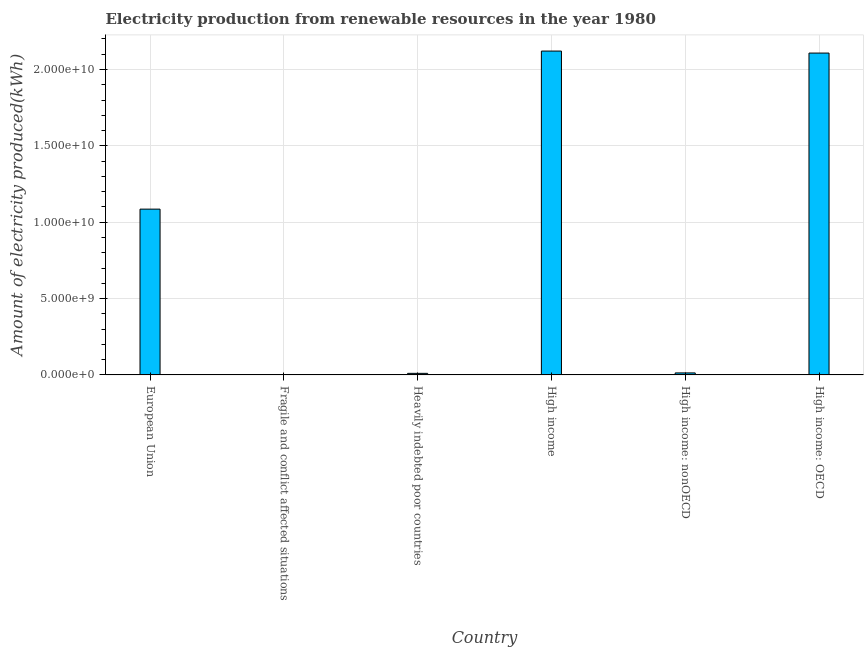Does the graph contain any zero values?
Offer a very short reply. No. What is the title of the graph?
Your answer should be very brief. Electricity production from renewable resources in the year 1980. What is the label or title of the X-axis?
Your answer should be compact. Country. What is the label or title of the Y-axis?
Your answer should be compact. Amount of electricity produced(kWh). What is the amount of electricity produced in Fragile and conflict affected situations?
Keep it short and to the point. 1.20e+07. Across all countries, what is the maximum amount of electricity produced?
Offer a terse response. 2.12e+1. Across all countries, what is the minimum amount of electricity produced?
Your answer should be very brief. 1.20e+07. In which country was the amount of electricity produced minimum?
Offer a very short reply. Fragile and conflict affected situations. What is the sum of the amount of electricity produced?
Your response must be concise. 5.34e+1. What is the difference between the amount of electricity produced in European Union and High income: nonOECD?
Offer a very short reply. 1.07e+1. What is the average amount of electricity produced per country?
Keep it short and to the point. 8.90e+09. What is the median amount of electricity produced?
Provide a succinct answer. 5.49e+09. In how many countries, is the amount of electricity produced greater than 19000000000 kWh?
Make the answer very short. 2. What is the ratio of the amount of electricity produced in Heavily indebted poor countries to that in High income?
Your response must be concise. 0.01. Is the difference between the amount of electricity produced in European Union and Heavily indebted poor countries greater than the difference between any two countries?
Keep it short and to the point. No. What is the difference between the highest and the second highest amount of electricity produced?
Your answer should be compact. 1.31e+08. What is the difference between the highest and the lowest amount of electricity produced?
Provide a succinct answer. 2.12e+1. How many bars are there?
Your answer should be compact. 6. Are all the bars in the graph horizontal?
Offer a very short reply. No. What is the difference between two consecutive major ticks on the Y-axis?
Provide a short and direct response. 5.00e+09. What is the Amount of electricity produced(kWh) of European Union?
Ensure brevity in your answer.  1.09e+1. What is the Amount of electricity produced(kWh) in Fragile and conflict affected situations?
Your answer should be compact. 1.20e+07. What is the Amount of electricity produced(kWh) of Heavily indebted poor countries?
Provide a short and direct response. 1.02e+08. What is the Amount of electricity produced(kWh) of High income?
Your answer should be very brief. 2.12e+1. What is the Amount of electricity produced(kWh) of High income: nonOECD?
Provide a succinct answer. 1.31e+08. What is the Amount of electricity produced(kWh) of High income: OECD?
Keep it short and to the point. 2.11e+1. What is the difference between the Amount of electricity produced(kWh) in European Union and Fragile and conflict affected situations?
Provide a succinct answer. 1.08e+1. What is the difference between the Amount of electricity produced(kWh) in European Union and Heavily indebted poor countries?
Your answer should be very brief. 1.08e+1. What is the difference between the Amount of electricity produced(kWh) in European Union and High income?
Your answer should be compact. -1.04e+1. What is the difference between the Amount of electricity produced(kWh) in European Union and High income: nonOECD?
Provide a succinct answer. 1.07e+1. What is the difference between the Amount of electricity produced(kWh) in European Union and High income: OECD?
Make the answer very short. -1.02e+1. What is the difference between the Amount of electricity produced(kWh) in Fragile and conflict affected situations and Heavily indebted poor countries?
Give a very brief answer. -9.00e+07. What is the difference between the Amount of electricity produced(kWh) in Fragile and conflict affected situations and High income?
Offer a terse response. -2.12e+1. What is the difference between the Amount of electricity produced(kWh) in Fragile and conflict affected situations and High income: nonOECD?
Your answer should be compact. -1.19e+08. What is the difference between the Amount of electricity produced(kWh) in Fragile and conflict affected situations and High income: OECD?
Keep it short and to the point. -2.11e+1. What is the difference between the Amount of electricity produced(kWh) in Heavily indebted poor countries and High income?
Your response must be concise. -2.11e+1. What is the difference between the Amount of electricity produced(kWh) in Heavily indebted poor countries and High income: nonOECD?
Ensure brevity in your answer.  -2.90e+07. What is the difference between the Amount of electricity produced(kWh) in Heavily indebted poor countries and High income: OECD?
Your answer should be compact. -2.10e+1. What is the difference between the Amount of electricity produced(kWh) in High income and High income: nonOECD?
Provide a succinct answer. 2.11e+1. What is the difference between the Amount of electricity produced(kWh) in High income and High income: OECD?
Provide a succinct answer. 1.31e+08. What is the difference between the Amount of electricity produced(kWh) in High income: nonOECD and High income: OECD?
Your answer should be compact. -2.09e+1. What is the ratio of the Amount of electricity produced(kWh) in European Union to that in Fragile and conflict affected situations?
Ensure brevity in your answer.  904.58. What is the ratio of the Amount of electricity produced(kWh) in European Union to that in Heavily indebted poor countries?
Offer a terse response. 106.42. What is the ratio of the Amount of electricity produced(kWh) in European Union to that in High income?
Offer a very short reply. 0.51. What is the ratio of the Amount of electricity produced(kWh) in European Union to that in High income: nonOECD?
Give a very brief answer. 82.86. What is the ratio of the Amount of electricity produced(kWh) in European Union to that in High income: OECD?
Your response must be concise. 0.52. What is the ratio of the Amount of electricity produced(kWh) in Fragile and conflict affected situations to that in Heavily indebted poor countries?
Make the answer very short. 0.12. What is the ratio of the Amount of electricity produced(kWh) in Fragile and conflict affected situations to that in High income?
Your answer should be compact. 0. What is the ratio of the Amount of electricity produced(kWh) in Fragile and conflict affected situations to that in High income: nonOECD?
Keep it short and to the point. 0.09. What is the ratio of the Amount of electricity produced(kWh) in Heavily indebted poor countries to that in High income?
Give a very brief answer. 0.01. What is the ratio of the Amount of electricity produced(kWh) in Heavily indebted poor countries to that in High income: nonOECD?
Your answer should be very brief. 0.78. What is the ratio of the Amount of electricity produced(kWh) in Heavily indebted poor countries to that in High income: OECD?
Offer a very short reply. 0.01. What is the ratio of the Amount of electricity produced(kWh) in High income to that in High income: nonOECD?
Offer a terse response. 161.87. What is the ratio of the Amount of electricity produced(kWh) in High income: nonOECD to that in High income: OECD?
Offer a very short reply. 0.01. 